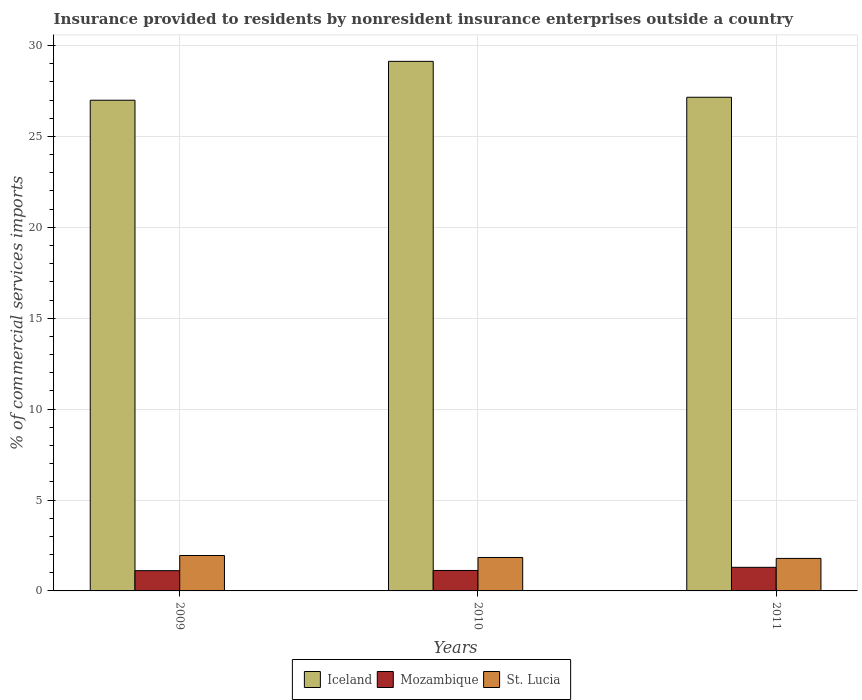Are the number of bars per tick equal to the number of legend labels?
Offer a very short reply. Yes. In how many cases, is the number of bars for a given year not equal to the number of legend labels?
Make the answer very short. 0. What is the Insurance provided to residents in St. Lucia in 2009?
Provide a short and direct response. 1.95. Across all years, what is the maximum Insurance provided to residents in St. Lucia?
Make the answer very short. 1.95. Across all years, what is the minimum Insurance provided to residents in St. Lucia?
Provide a short and direct response. 1.79. In which year was the Insurance provided to residents in Mozambique minimum?
Give a very brief answer. 2009. What is the total Insurance provided to residents in Iceland in the graph?
Provide a succinct answer. 83.28. What is the difference between the Insurance provided to residents in St. Lucia in 2010 and that in 2011?
Your response must be concise. 0.05. What is the difference between the Insurance provided to residents in St. Lucia in 2011 and the Insurance provided to residents in Iceland in 2009?
Offer a terse response. -25.2. What is the average Insurance provided to residents in St. Lucia per year?
Offer a terse response. 1.86. In the year 2011, what is the difference between the Insurance provided to residents in St. Lucia and Insurance provided to residents in Iceland?
Your response must be concise. -25.37. What is the ratio of the Insurance provided to residents in Iceland in 2009 to that in 2010?
Your response must be concise. 0.93. Is the Insurance provided to residents in Mozambique in 2009 less than that in 2010?
Ensure brevity in your answer.  Yes. Is the difference between the Insurance provided to residents in St. Lucia in 2009 and 2011 greater than the difference between the Insurance provided to residents in Iceland in 2009 and 2011?
Your answer should be compact. Yes. What is the difference between the highest and the second highest Insurance provided to residents in Iceland?
Your answer should be very brief. 1.98. What is the difference between the highest and the lowest Insurance provided to residents in Mozambique?
Keep it short and to the point. 0.18. In how many years, is the Insurance provided to residents in Mozambique greater than the average Insurance provided to residents in Mozambique taken over all years?
Your answer should be compact. 1. Is the sum of the Insurance provided to residents in Iceland in 2009 and 2011 greater than the maximum Insurance provided to residents in Mozambique across all years?
Provide a succinct answer. Yes. What does the 3rd bar from the left in 2009 represents?
Your answer should be compact. St. Lucia. What does the 2nd bar from the right in 2010 represents?
Provide a succinct answer. Mozambique. Is it the case that in every year, the sum of the Insurance provided to residents in St. Lucia and Insurance provided to residents in Iceland is greater than the Insurance provided to residents in Mozambique?
Provide a succinct answer. Yes. What is the difference between two consecutive major ticks on the Y-axis?
Ensure brevity in your answer.  5. Does the graph contain any zero values?
Offer a very short reply. No. How are the legend labels stacked?
Ensure brevity in your answer.  Horizontal. What is the title of the graph?
Your response must be concise. Insurance provided to residents by nonresident insurance enterprises outside a country. Does "St. Vincent and the Grenadines" appear as one of the legend labels in the graph?
Make the answer very short. No. What is the label or title of the X-axis?
Offer a very short reply. Years. What is the label or title of the Y-axis?
Your response must be concise. % of commercial services imports. What is the % of commercial services imports in Iceland in 2009?
Offer a very short reply. 26.99. What is the % of commercial services imports of Mozambique in 2009?
Offer a terse response. 1.11. What is the % of commercial services imports of St. Lucia in 2009?
Offer a very short reply. 1.95. What is the % of commercial services imports of Iceland in 2010?
Make the answer very short. 29.13. What is the % of commercial services imports in Mozambique in 2010?
Provide a short and direct response. 1.13. What is the % of commercial services imports in St. Lucia in 2010?
Keep it short and to the point. 1.84. What is the % of commercial services imports in Iceland in 2011?
Keep it short and to the point. 27.16. What is the % of commercial services imports in Mozambique in 2011?
Keep it short and to the point. 1.3. What is the % of commercial services imports in St. Lucia in 2011?
Provide a succinct answer. 1.79. Across all years, what is the maximum % of commercial services imports of Iceland?
Offer a very short reply. 29.13. Across all years, what is the maximum % of commercial services imports of Mozambique?
Your answer should be compact. 1.3. Across all years, what is the maximum % of commercial services imports of St. Lucia?
Your response must be concise. 1.95. Across all years, what is the minimum % of commercial services imports of Iceland?
Ensure brevity in your answer.  26.99. Across all years, what is the minimum % of commercial services imports in Mozambique?
Your response must be concise. 1.11. Across all years, what is the minimum % of commercial services imports of St. Lucia?
Keep it short and to the point. 1.79. What is the total % of commercial services imports in Iceland in the graph?
Keep it short and to the point. 83.28. What is the total % of commercial services imports of Mozambique in the graph?
Make the answer very short. 3.54. What is the total % of commercial services imports in St. Lucia in the graph?
Provide a succinct answer. 5.57. What is the difference between the % of commercial services imports of Iceland in 2009 and that in 2010?
Provide a succinct answer. -2.14. What is the difference between the % of commercial services imports of Mozambique in 2009 and that in 2010?
Your answer should be compact. -0.01. What is the difference between the % of commercial services imports of St. Lucia in 2009 and that in 2010?
Offer a very short reply. 0.11. What is the difference between the % of commercial services imports of Iceland in 2009 and that in 2011?
Your response must be concise. -0.16. What is the difference between the % of commercial services imports in Mozambique in 2009 and that in 2011?
Make the answer very short. -0.18. What is the difference between the % of commercial services imports in St. Lucia in 2009 and that in 2011?
Provide a succinct answer. 0.16. What is the difference between the % of commercial services imports in Iceland in 2010 and that in 2011?
Offer a very short reply. 1.98. What is the difference between the % of commercial services imports in Mozambique in 2010 and that in 2011?
Your response must be concise. -0.17. What is the difference between the % of commercial services imports in St. Lucia in 2010 and that in 2011?
Provide a succinct answer. 0.05. What is the difference between the % of commercial services imports in Iceland in 2009 and the % of commercial services imports in Mozambique in 2010?
Your answer should be very brief. 25.87. What is the difference between the % of commercial services imports in Iceland in 2009 and the % of commercial services imports in St. Lucia in 2010?
Give a very brief answer. 25.15. What is the difference between the % of commercial services imports in Mozambique in 2009 and the % of commercial services imports in St. Lucia in 2010?
Your answer should be compact. -0.72. What is the difference between the % of commercial services imports in Iceland in 2009 and the % of commercial services imports in Mozambique in 2011?
Your answer should be very brief. 25.69. What is the difference between the % of commercial services imports of Iceland in 2009 and the % of commercial services imports of St. Lucia in 2011?
Keep it short and to the point. 25.2. What is the difference between the % of commercial services imports of Mozambique in 2009 and the % of commercial services imports of St. Lucia in 2011?
Make the answer very short. -0.67. What is the difference between the % of commercial services imports of Iceland in 2010 and the % of commercial services imports of Mozambique in 2011?
Make the answer very short. 27.83. What is the difference between the % of commercial services imports of Iceland in 2010 and the % of commercial services imports of St. Lucia in 2011?
Ensure brevity in your answer.  27.34. What is the difference between the % of commercial services imports of Mozambique in 2010 and the % of commercial services imports of St. Lucia in 2011?
Make the answer very short. -0.66. What is the average % of commercial services imports of Iceland per year?
Offer a very short reply. 27.76. What is the average % of commercial services imports of Mozambique per year?
Your response must be concise. 1.18. What is the average % of commercial services imports in St. Lucia per year?
Your response must be concise. 1.86. In the year 2009, what is the difference between the % of commercial services imports in Iceland and % of commercial services imports in Mozambique?
Give a very brief answer. 25.88. In the year 2009, what is the difference between the % of commercial services imports in Iceland and % of commercial services imports in St. Lucia?
Make the answer very short. 25.04. In the year 2009, what is the difference between the % of commercial services imports in Mozambique and % of commercial services imports in St. Lucia?
Ensure brevity in your answer.  -0.83. In the year 2010, what is the difference between the % of commercial services imports of Iceland and % of commercial services imports of Mozambique?
Ensure brevity in your answer.  28. In the year 2010, what is the difference between the % of commercial services imports of Iceland and % of commercial services imports of St. Lucia?
Your response must be concise. 27.29. In the year 2010, what is the difference between the % of commercial services imports of Mozambique and % of commercial services imports of St. Lucia?
Provide a short and direct response. -0.71. In the year 2011, what is the difference between the % of commercial services imports of Iceland and % of commercial services imports of Mozambique?
Your answer should be very brief. 25.86. In the year 2011, what is the difference between the % of commercial services imports of Iceland and % of commercial services imports of St. Lucia?
Make the answer very short. 25.37. In the year 2011, what is the difference between the % of commercial services imports in Mozambique and % of commercial services imports in St. Lucia?
Make the answer very short. -0.49. What is the ratio of the % of commercial services imports of Iceland in 2009 to that in 2010?
Make the answer very short. 0.93. What is the ratio of the % of commercial services imports of St. Lucia in 2009 to that in 2010?
Keep it short and to the point. 1.06. What is the ratio of the % of commercial services imports in Mozambique in 2009 to that in 2011?
Ensure brevity in your answer.  0.86. What is the ratio of the % of commercial services imports of St. Lucia in 2009 to that in 2011?
Provide a succinct answer. 1.09. What is the ratio of the % of commercial services imports of Iceland in 2010 to that in 2011?
Give a very brief answer. 1.07. What is the ratio of the % of commercial services imports in Mozambique in 2010 to that in 2011?
Keep it short and to the point. 0.87. What is the ratio of the % of commercial services imports in St. Lucia in 2010 to that in 2011?
Your response must be concise. 1.03. What is the difference between the highest and the second highest % of commercial services imports in Iceland?
Give a very brief answer. 1.98. What is the difference between the highest and the second highest % of commercial services imports of Mozambique?
Your response must be concise. 0.17. What is the difference between the highest and the second highest % of commercial services imports of St. Lucia?
Provide a succinct answer. 0.11. What is the difference between the highest and the lowest % of commercial services imports in Iceland?
Offer a very short reply. 2.14. What is the difference between the highest and the lowest % of commercial services imports in Mozambique?
Your response must be concise. 0.18. What is the difference between the highest and the lowest % of commercial services imports of St. Lucia?
Keep it short and to the point. 0.16. 